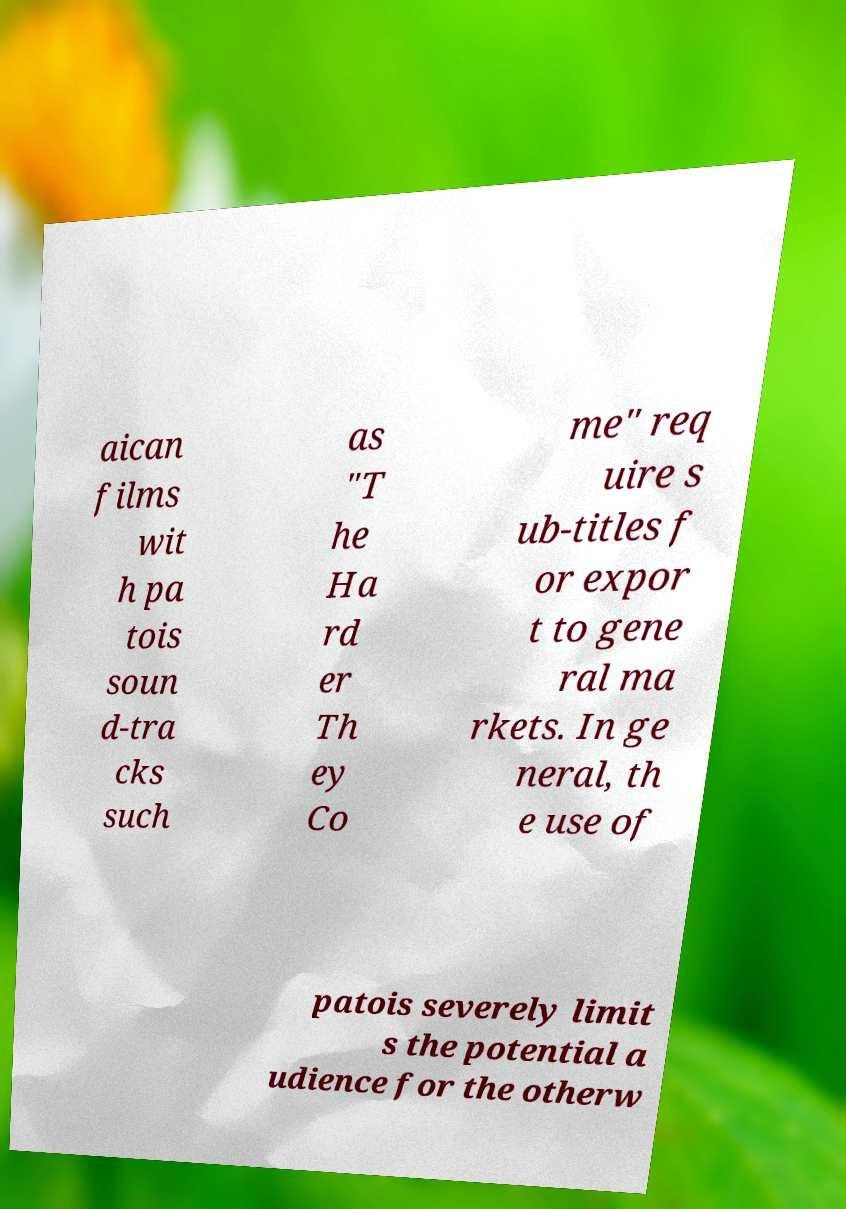Please read and relay the text visible in this image. What does it say? aican films wit h pa tois soun d-tra cks such as "T he Ha rd er Th ey Co me" req uire s ub-titles f or expor t to gene ral ma rkets. In ge neral, th e use of patois severely limit s the potential a udience for the otherw 